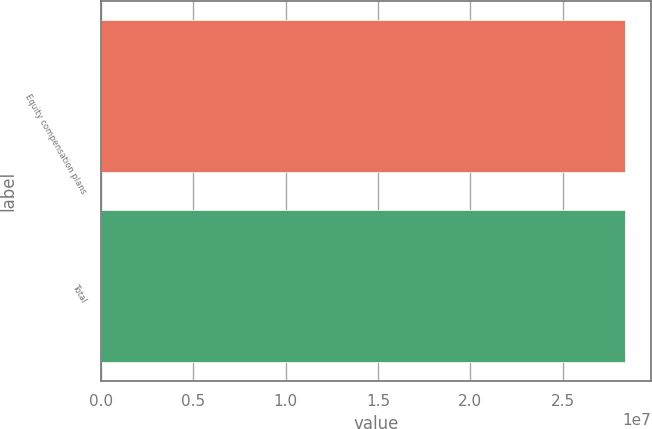<chart> <loc_0><loc_0><loc_500><loc_500><bar_chart><fcel>Equity compensation plans<fcel>Total<nl><fcel>2.83789e+07<fcel>2.83789e+07<nl></chart> 